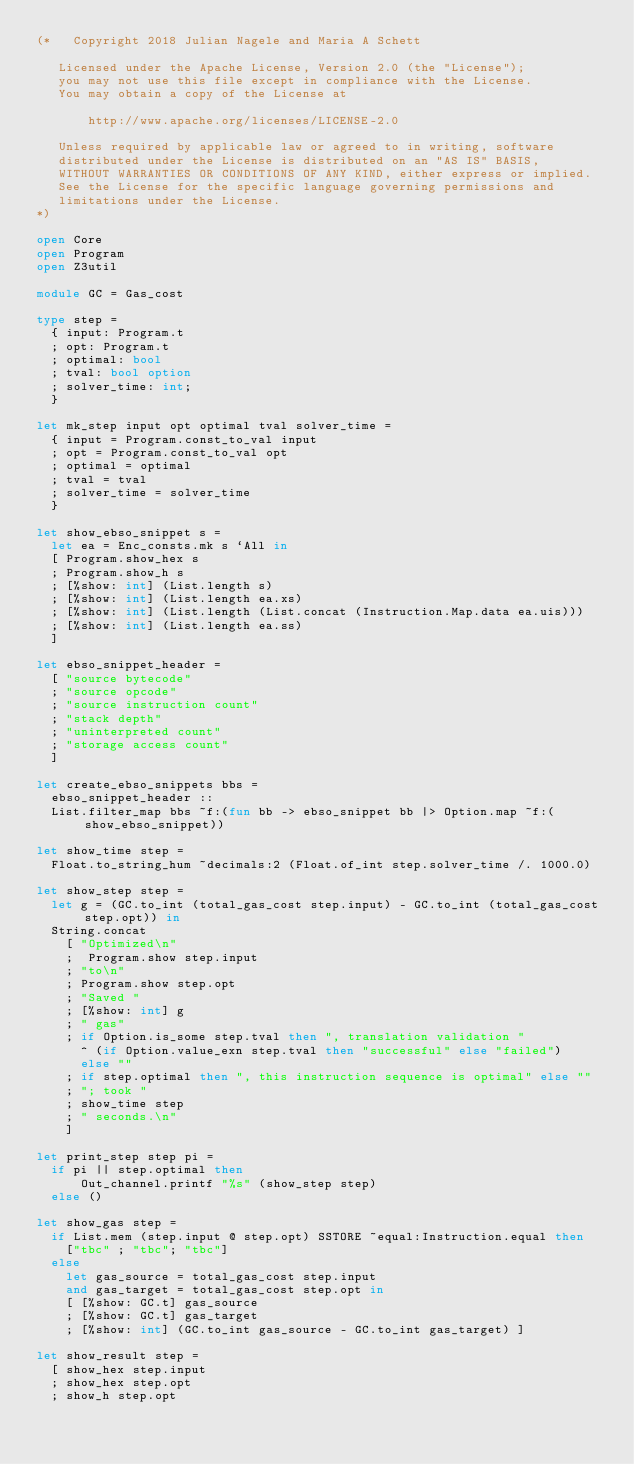<code> <loc_0><loc_0><loc_500><loc_500><_OCaml_>(*   Copyright 2018 Julian Nagele and Maria A Schett

   Licensed under the Apache License, Version 2.0 (the "License");
   you may not use this file except in compliance with the License.
   You may obtain a copy of the License at

       http://www.apache.org/licenses/LICENSE-2.0

   Unless required by applicable law or agreed to in writing, software
   distributed under the License is distributed on an "AS IS" BASIS,
   WITHOUT WARRANTIES OR CONDITIONS OF ANY KIND, either express or implied.
   See the License for the specific language governing permissions and
   limitations under the License.
*)

open Core
open Program
open Z3util

module GC = Gas_cost

type step =
  { input: Program.t
  ; opt: Program.t
  ; optimal: bool
  ; tval: bool option
  ; solver_time: int;
  }

let mk_step input opt optimal tval solver_time =
  { input = Program.const_to_val input
  ; opt = Program.const_to_val opt
  ; optimal = optimal
  ; tval = tval
  ; solver_time = solver_time
  }

let show_ebso_snippet s =
  let ea = Enc_consts.mk s `All in
  [ Program.show_hex s
  ; Program.show_h s
  ; [%show: int] (List.length s)
  ; [%show: int] (List.length ea.xs)
  ; [%show: int] (List.length (List.concat (Instruction.Map.data ea.uis)))
  ; [%show: int] (List.length ea.ss)
  ]

let ebso_snippet_header =
  [ "source bytecode"
  ; "source opcode"
  ; "source instruction count"
  ; "stack depth"
  ; "uninterpreted count"
  ; "storage access count"
  ]

let create_ebso_snippets bbs =
  ebso_snippet_header ::
  List.filter_map bbs ~f:(fun bb -> ebso_snippet bb |> Option.map ~f:(show_ebso_snippet))

let show_time step =
  Float.to_string_hum ~decimals:2 (Float.of_int step.solver_time /. 1000.0)

let show_step step =
  let g = (GC.to_int (total_gas_cost step.input) - GC.to_int (total_gas_cost step.opt)) in
  String.concat
    [ "Optimized\n"
    ;  Program.show step.input
    ; "to\n"
    ; Program.show step.opt
    ; "Saved "
    ; [%show: int] g
    ; " gas"
    ; if Option.is_some step.tval then ", translation validation "
      ^ (if Option.value_exn step.tval then "successful" else "failed")
      else ""
    ; if step.optimal then ", this instruction sequence is optimal" else ""
    ; "; took "
    ; show_time step
    ; " seconds.\n"
    ]

let print_step step pi =
  if pi || step.optimal then
      Out_channel.printf "%s" (show_step step)
  else ()

let show_gas step =
  if List.mem (step.input @ step.opt) SSTORE ~equal:Instruction.equal then
    ["tbc" ; "tbc"; "tbc"]
  else
    let gas_source = total_gas_cost step.input
    and gas_target = total_gas_cost step.opt in
    [ [%show: GC.t] gas_source
    ; [%show: GC.t] gas_target
    ; [%show: int] (GC.to_int gas_source - GC.to_int gas_target) ]

let show_result step =
  [ show_hex step.input
  ; show_hex step.opt
  ; show_h step.opt</code> 